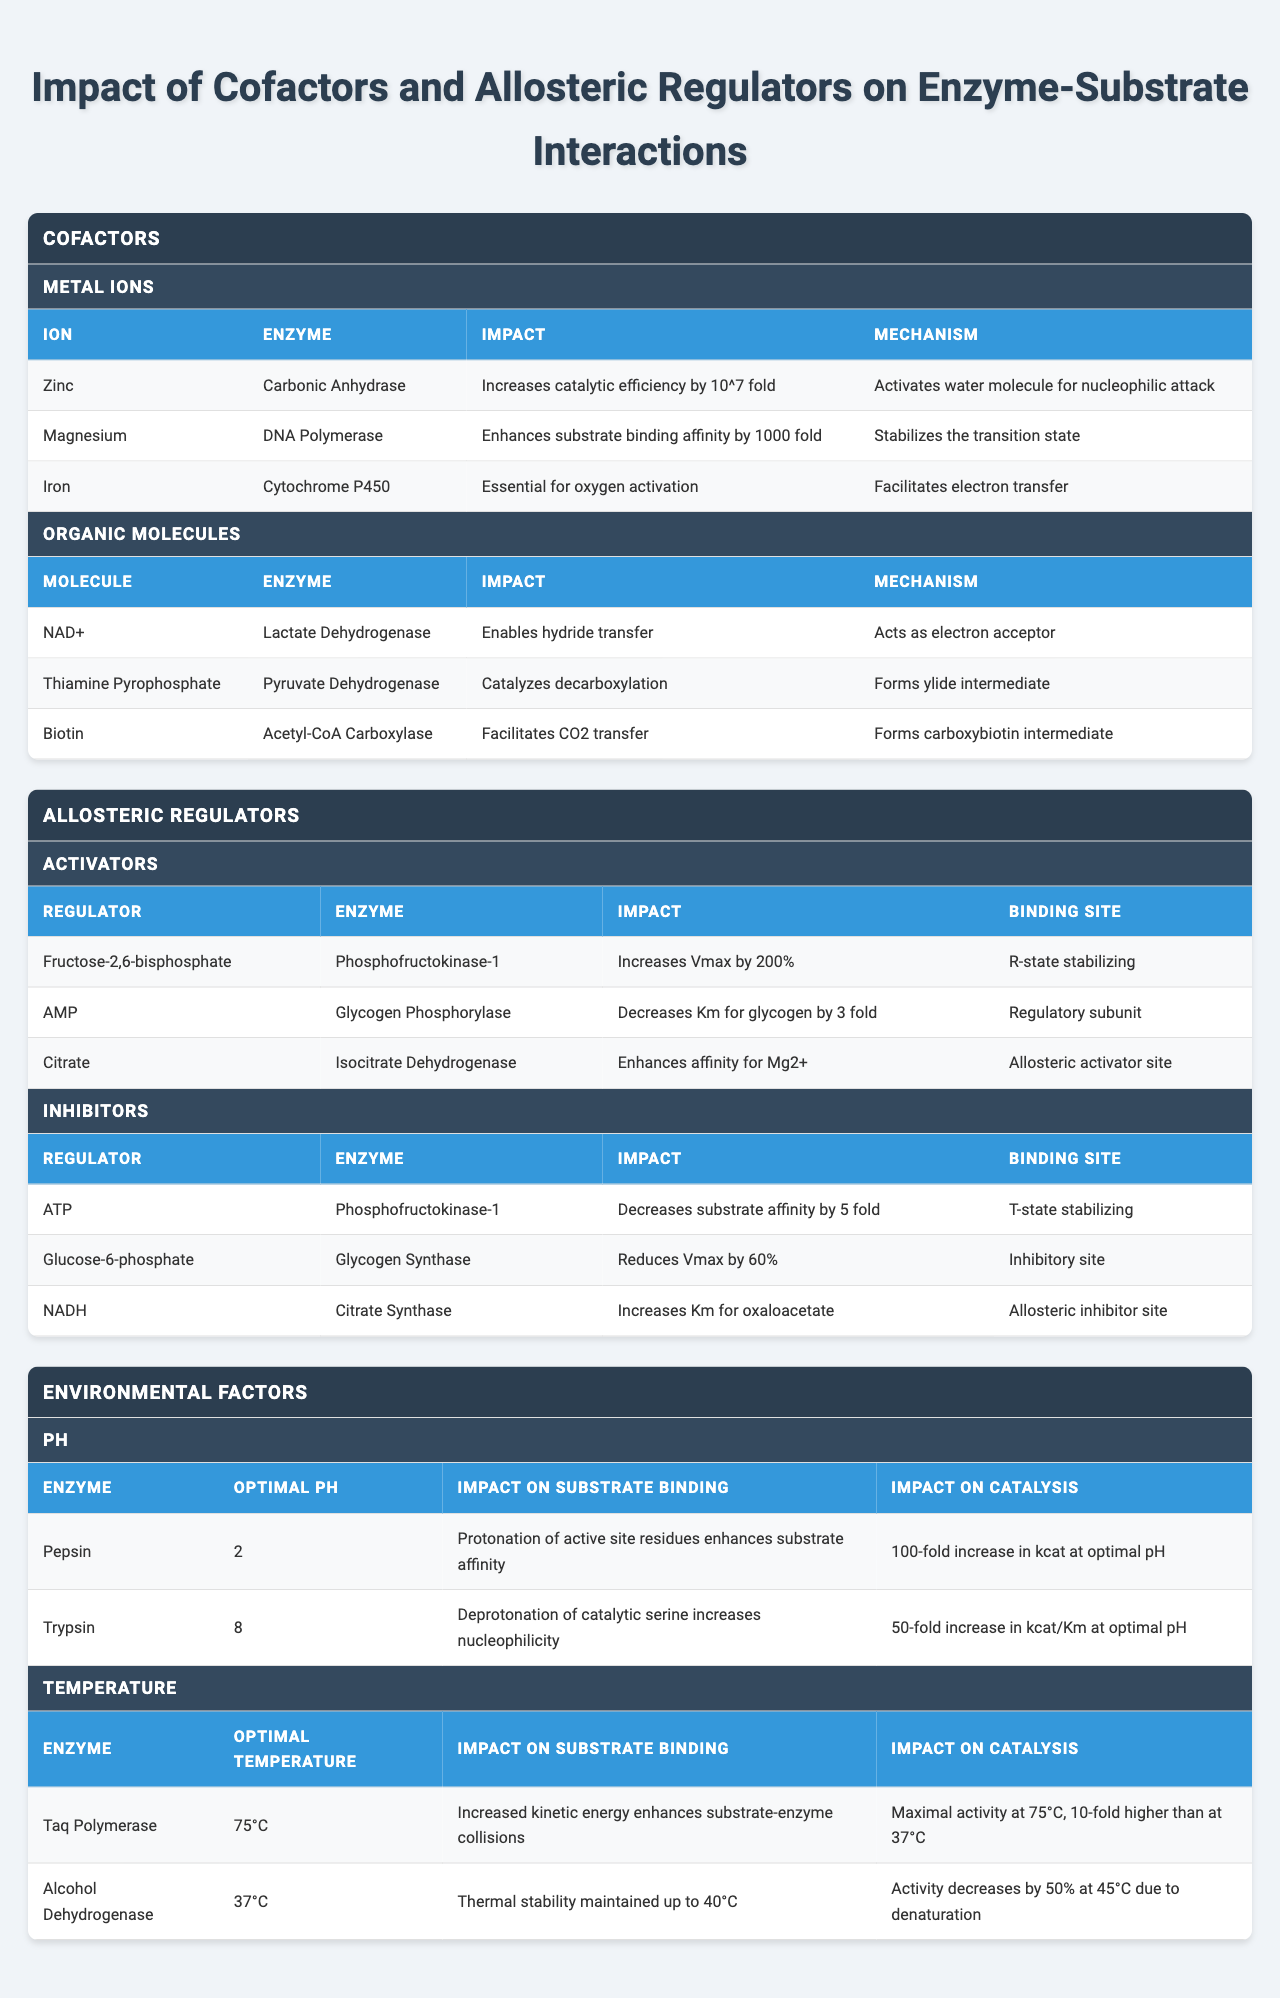What impact does Zinc have on Carbonic Anhydrase? The table indicates that Zinc increases the catalytic efficiency of Carbonic Anhydrase by 10^7 fold.
Answer: Increases catalytic efficiency by 10^7 fold Which allosteric regulator decreases the substrate affinity for Phosphofructokinase-1? The table lists ATP as an inhibitor of Phosphofructokinase-1, stating it decreases substrate affinity by 5 fold.
Answer: ATP What is the impact of Magnesium on DNA Polymerase? According to the table, Magnesium enhances substrate binding affinity for DNA Polymerase by 1000 fold.
Answer: Enhances substrate binding affinity by 1000 fold Is Fructose-2,6-bisphosphate an inhibitor for any enzyme? The table categorizes Fructose-2,6-bisphosphate as an activator for Phosphofructokinase-1, not an inhibitor. Therefore, the answer is no.
Answer: No What is the optimal pH for Pepsin, and how does it affect substrate binding? Pepsin has an optimal pH of 2, which enhances substrate affinity by protonating active site residues.
Answer: Optimal pH is 2; enhances substrate affinity Which enzyme shows a significant temperature effect of activity at 45°C? The table shows that Alcohol Dehydrogenase decreases its activity by 50% at 45°C due to denaturation.
Answer: Alcohol Dehydrogenase How do the impacts of allosteric activators compare to inhibiting regulators for the same enzymes? For Phosphofructokinase-1, Fructose-2,6-bisphosphate (an activator) increases Vmax by 200% while ATP (an inhibitor) decreases substrate affinity by 5 fold. This indicates opposing effects on enzyme activity.
Answer: They have opposing effects on enzyme activity What mechanism allows Iron to facilitate its role in Cytochrome P450? The table states that Iron facilitates electron transfer, which is vital for the oxygen activation process in Cytochrome P450.
Answer: Facilitates electron transfer Which enzyme has the lowest optimal pH and highest increase in kcat? Pepsin has the lowest optimal pH at 2 and shows a 100-fold increase in kcat at optimum conditions, according to the table.
Answer: Pepsin Which organic molecule aids in CO2 transfer and with which enzyme is it associated? Biotin facilitates CO2 transfer and is associated with Acetyl-CoA Carboxylase, as shown in the table.
Answer: Biotin with Acetyl-CoA Carboxylase What is the average catalytic impact of allosteric activators on the enzymes listed? The total impacts on Vmax from activators (200% for Phosphofructokinase-1, no numeric impacts for others listed) averages out to a qualitative increase since specifics are not quantified for others.
Answer: Qualitative increase 